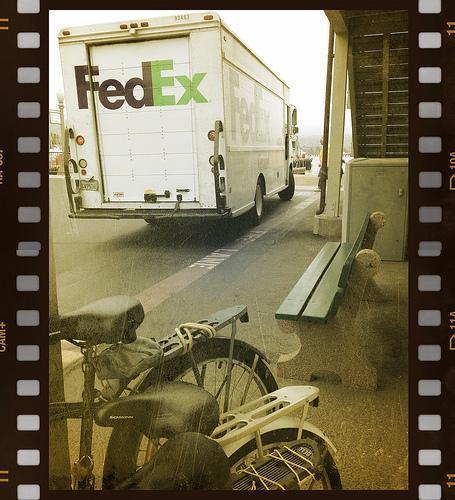How many bicycles are there?
Give a very brief answer. 2. How many bike tires are visible?
Give a very brief answer. 2. 